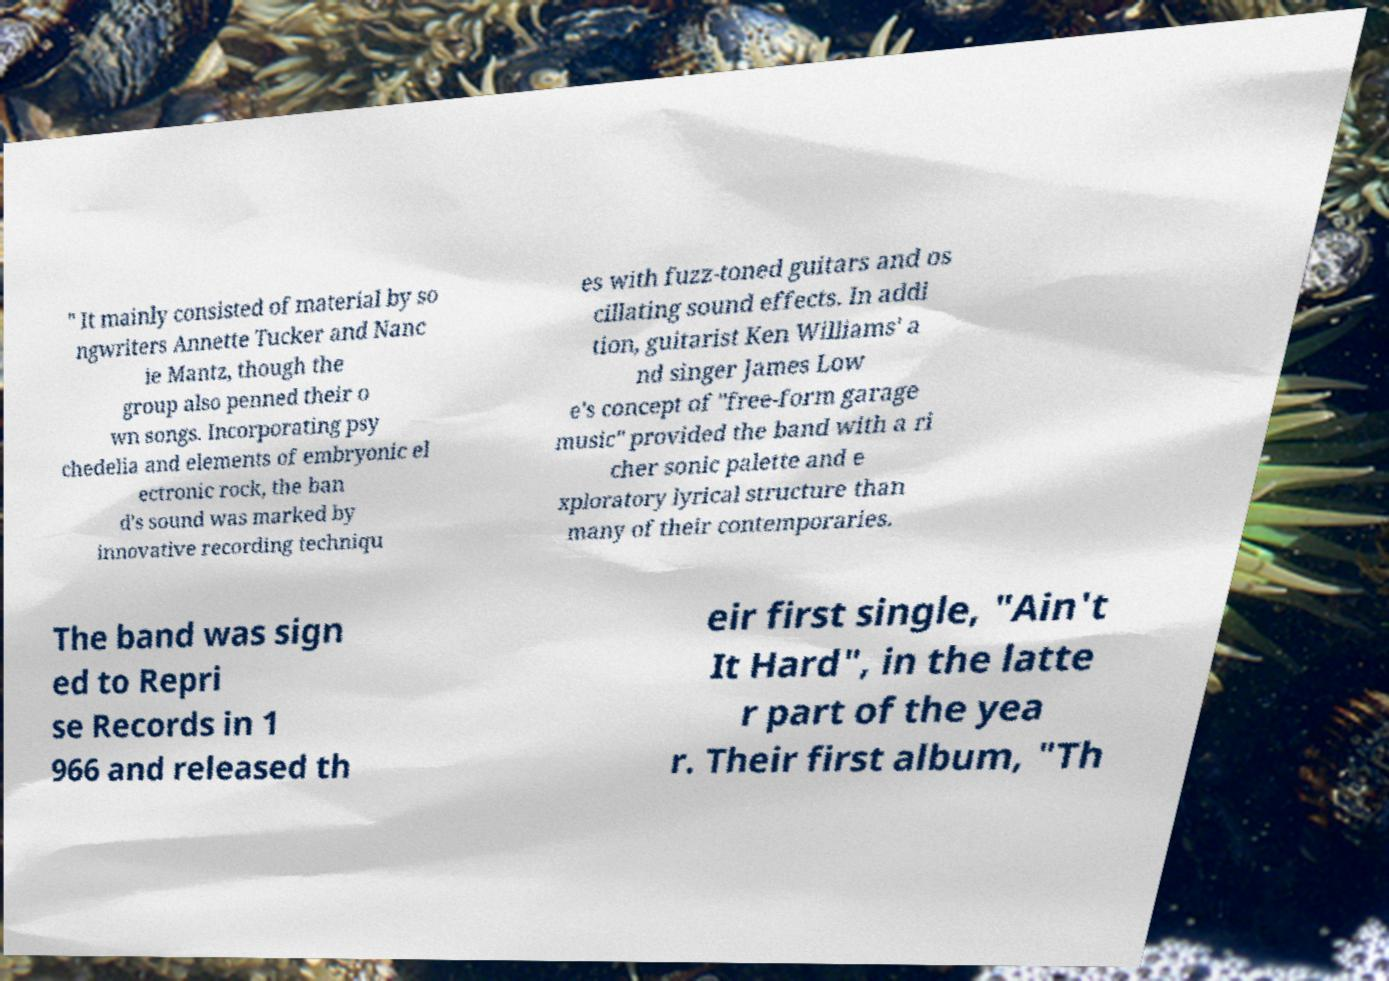Please read and relay the text visible in this image. What does it say? " It mainly consisted of material by so ngwriters Annette Tucker and Nanc ie Mantz, though the group also penned their o wn songs. Incorporating psy chedelia and elements of embryonic el ectronic rock, the ban d's sound was marked by innovative recording techniqu es with fuzz-toned guitars and os cillating sound effects. In addi tion, guitarist Ken Williams' a nd singer James Low e's concept of "free-form garage music" provided the band with a ri cher sonic palette and e xploratory lyrical structure than many of their contemporaries. The band was sign ed to Repri se Records in 1 966 and released th eir first single, "Ain't It Hard", in the latte r part of the yea r. Their first album, "Th 